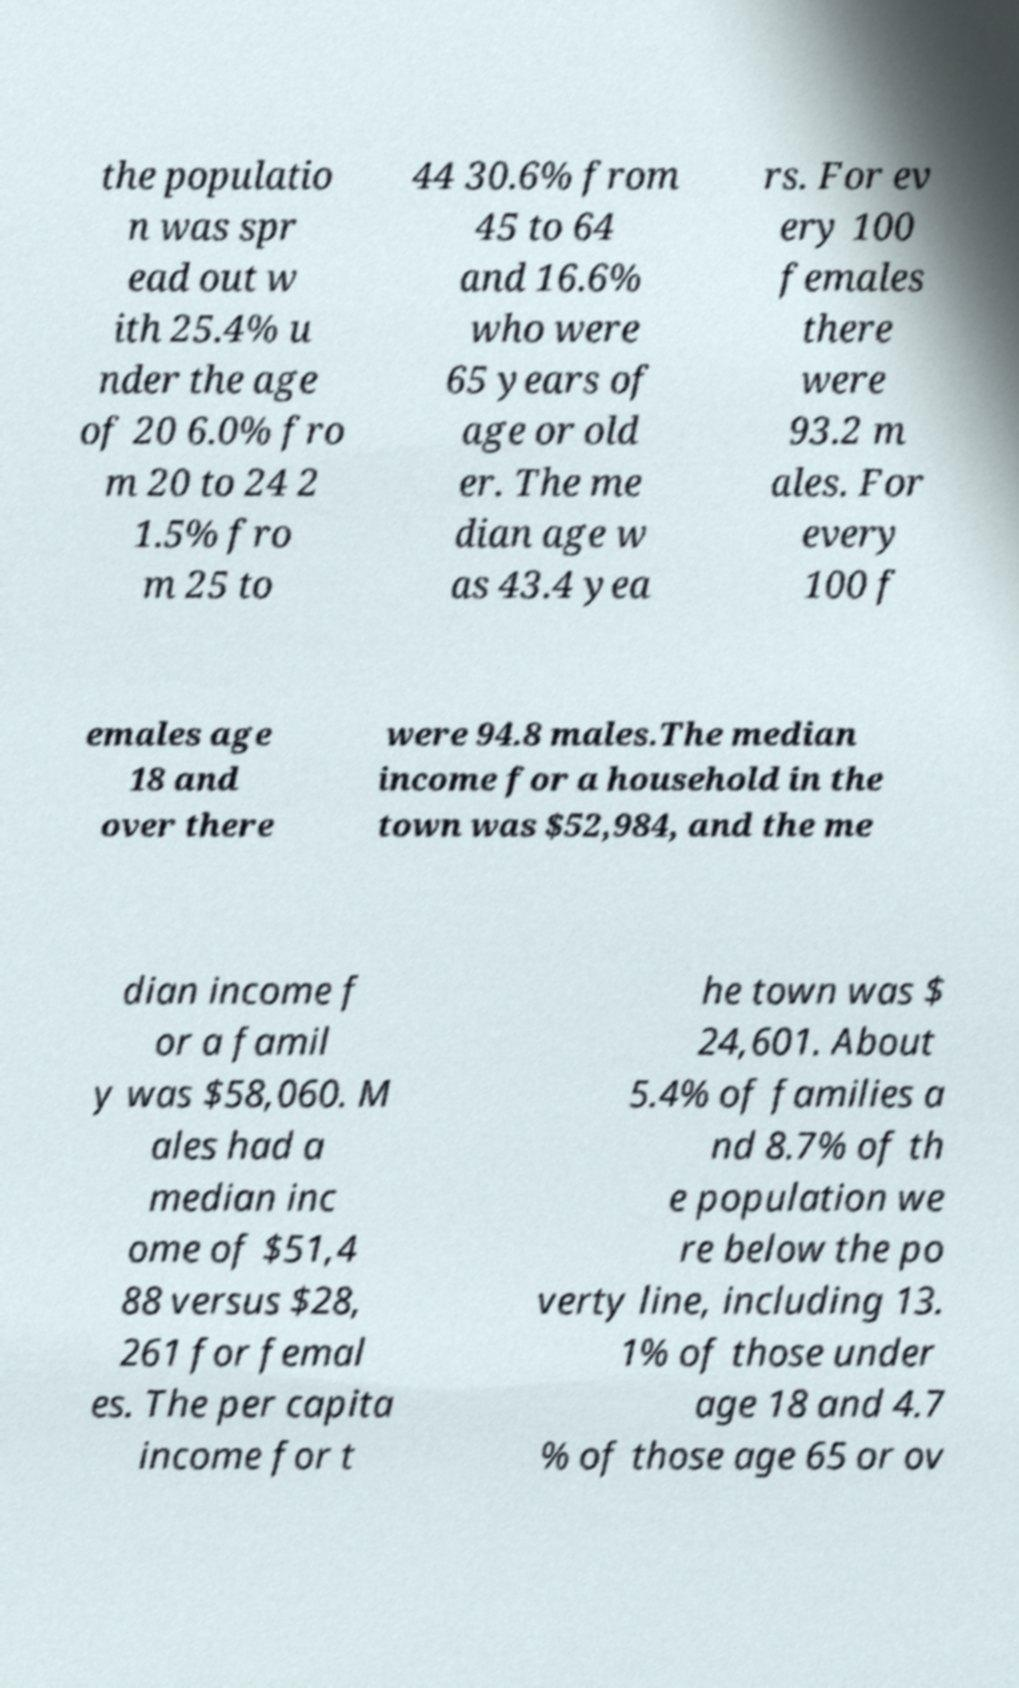Please identify and transcribe the text found in this image. the populatio n was spr ead out w ith 25.4% u nder the age of 20 6.0% fro m 20 to 24 2 1.5% fro m 25 to 44 30.6% from 45 to 64 and 16.6% who were 65 years of age or old er. The me dian age w as 43.4 yea rs. For ev ery 100 females there were 93.2 m ales. For every 100 f emales age 18 and over there were 94.8 males.The median income for a household in the town was $52,984, and the me dian income f or a famil y was $58,060. M ales had a median inc ome of $51,4 88 versus $28, 261 for femal es. The per capita income for t he town was $ 24,601. About 5.4% of families a nd 8.7% of th e population we re below the po verty line, including 13. 1% of those under age 18 and 4.7 % of those age 65 or ov 